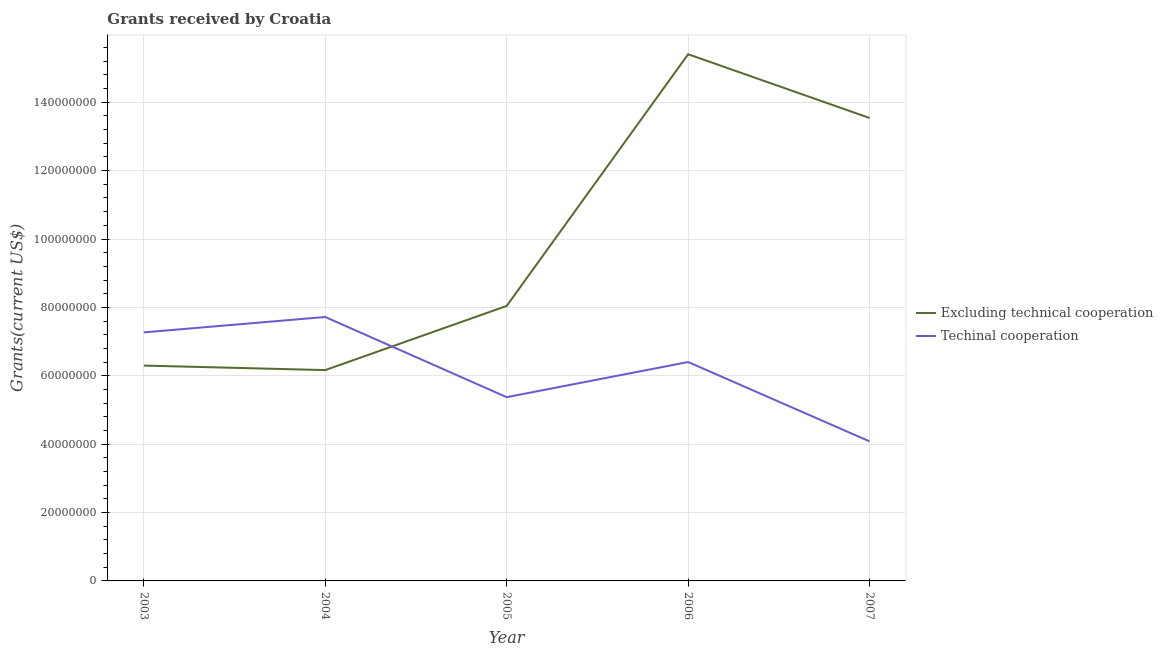What is the amount of grants received(including technical cooperation) in 2003?
Offer a terse response. 7.27e+07. Across all years, what is the maximum amount of grants received(excluding technical cooperation)?
Keep it short and to the point. 1.54e+08. Across all years, what is the minimum amount of grants received(excluding technical cooperation)?
Your response must be concise. 6.17e+07. What is the total amount of grants received(including technical cooperation) in the graph?
Make the answer very short. 3.08e+08. What is the difference between the amount of grants received(including technical cooperation) in 2004 and that in 2005?
Provide a succinct answer. 2.34e+07. What is the difference between the amount of grants received(including technical cooperation) in 2004 and the amount of grants received(excluding technical cooperation) in 2007?
Give a very brief answer. -5.82e+07. What is the average amount of grants received(including technical cooperation) per year?
Your answer should be very brief. 6.17e+07. In the year 2003, what is the difference between the amount of grants received(including technical cooperation) and amount of grants received(excluding technical cooperation)?
Your answer should be very brief. 9.71e+06. In how many years, is the amount of grants received(excluding technical cooperation) greater than 44000000 US$?
Your answer should be compact. 5. What is the ratio of the amount of grants received(excluding technical cooperation) in 2004 to that in 2005?
Your answer should be compact. 0.77. Is the amount of grants received(excluding technical cooperation) in 2005 less than that in 2006?
Offer a terse response. Yes. What is the difference between the highest and the second highest amount of grants received(including technical cooperation)?
Offer a very short reply. 4.50e+06. What is the difference between the highest and the lowest amount of grants received(excluding technical cooperation)?
Keep it short and to the point. 9.24e+07. Is the sum of the amount of grants received(excluding technical cooperation) in 2004 and 2005 greater than the maximum amount of grants received(including technical cooperation) across all years?
Your response must be concise. Yes. Is the amount of grants received(excluding technical cooperation) strictly less than the amount of grants received(including technical cooperation) over the years?
Give a very brief answer. No. Are the values on the major ticks of Y-axis written in scientific E-notation?
Give a very brief answer. No. Where does the legend appear in the graph?
Ensure brevity in your answer.  Center right. What is the title of the graph?
Keep it short and to the point. Grants received by Croatia. What is the label or title of the X-axis?
Your answer should be very brief. Year. What is the label or title of the Y-axis?
Provide a succinct answer. Grants(current US$). What is the Grants(current US$) of Excluding technical cooperation in 2003?
Make the answer very short. 6.30e+07. What is the Grants(current US$) of Techinal cooperation in 2003?
Ensure brevity in your answer.  7.27e+07. What is the Grants(current US$) of Excluding technical cooperation in 2004?
Keep it short and to the point. 6.17e+07. What is the Grants(current US$) in Techinal cooperation in 2004?
Keep it short and to the point. 7.72e+07. What is the Grants(current US$) of Excluding technical cooperation in 2005?
Provide a short and direct response. 8.04e+07. What is the Grants(current US$) of Techinal cooperation in 2005?
Offer a terse response. 5.37e+07. What is the Grants(current US$) of Excluding technical cooperation in 2006?
Provide a succinct answer. 1.54e+08. What is the Grants(current US$) in Techinal cooperation in 2006?
Your answer should be compact. 6.40e+07. What is the Grants(current US$) of Excluding technical cooperation in 2007?
Provide a short and direct response. 1.35e+08. What is the Grants(current US$) in Techinal cooperation in 2007?
Your answer should be very brief. 4.08e+07. Across all years, what is the maximum Grants(current US$) of Excluding technical cooperation?
Ensure brevity in your answer.  1.54e+08. Across all years, what is the maximum Grants(current US$) of Techinal cooperation?
Provide a succinct answer. 7.72e+07. Across all years, what is the minimum Grants(current US$) in Excluding technical cooperation?
Provide a succinct answer. 6.17e+07. Across all years, what is the minimum Grants(current US$) in Techinal cooperation?
Ensure brevity in your answer.  4.08e+07. What is the total Grants(current US$) in Excluding technical cooperation in the graph?
Ensure brevity in your answer.  4.94e+08. What is the total Grants(current US$) of Techinal cooperation in the graph?
Give a very brief answer. 3.08e+08. What is the difference between the Grants(current US$) of Excluding technical cooperation in 2003 and that in 2004?
Offer a very short reply. 1.32e+06. What is the difference between the Grants(current US$) of Techinal cooperation in 2003 and that in 2004?
Keep it short and to the point. -4.50e+06. What is the difference between the Grants(current US$) in Excluding technical cooperation in 2003 and that in 2005?
Keep it short and to the point. -1.74e+07. What is the difference between the Grants(current US$) in Techinal cooperation in 2003 and that in 2005?
Keep it short and to the point. 1.90e+07. What is the difference between the Grants(current US$) of Excluding technical cooperation in 2003 and that in 2006?
Provide a succinct answer. -9.11e+07. What is the difference between the Grants(current US$) in Techinal cooperation in 2003 and that in 2006?
Give a very brief answer. 8.67e+06. What is the difference between the Grants(current US$) of Excluding technical cooperation in 2003 and that in 2007?
Offer a very short reply. -7.24e+07. What is the difference between the Grants(current US$) in Techinal cooperation in 2003 and that in 2007?
Ensure brevity in your answer.  3.19e+07. What is the difference between the Grants(current US$) in Excluding technical cooperation in 2004 and that in 2005?
Ensure brevity in your answer.  -1.88e+07. What is the difference between the Grants(current US$) of Techinal cooperation in 2004 and that in 2005?
Offer a terse response. 2.34e+07. What is the difference between the Grants(current US$) of Excluding technical cooperation in 2004 and that in 2006?
Give a very brief answer. -9.24e+07. What is the difference between the Grants(current US$) in Techinal cooperation in 2004 and that in 2006?
Your answer should be very brief. 1.32e+07. What is the difference between the Grants(current US$) in Excluding technical cooperation in 2004 and that in 2007?
Ensure brevity in your answer.  -7.37e+07. What is the difference between the Grants(current US$) in Techinal cooperation in 2004 and that in 2007?
Provide a succinct answer. 3.64e+07. What is the difference between the Grants(current US$) of Excluding technical cooperation in 2005 and that in 2006?
Keep it short and to the point. -7.36e+07. What is the difference between the Grants(current US$) in Techinal cooperation in 2005 and that in 2006?
Your answer should be very brief. -1.03e+07. What is the difference between the Grants(current US$) in Excluding technical cooperation in 2005 and that in 2007?
Offer a very short reply. -5.50e+07. What is the difference between the Grants(current US$) of Techinal cooperation in 2005 and that in 2007?
Your answer should be very brief. 1.29e+07. What is the difference between the Grants(current US$) in Excluding technical cooperation in 2006 and that in 2007?
Offer a terse response. 1.86e+07. What is the difference between the Grants(current US$) of Techinal cooperation in 2006 and that in 2007?
Your answer should be very brief. 2.32e+07. What is the difference between the Grants(current US$) of Excluding technical cooperation in 2003 and the Grants(current US$) of Techinal cooperation in 2004?
Provide a short and direct response. -1.42e+07. What is the difference between the Grants(current US$) of Excluding technical cooperation in 2003 and the Grants(current US$) of Techinal cooperation in 2005?
Provide a succinct answer. 9.24e+06. What is the difference between the Grants(current US$) of Excluding technical cooperation in 2003 and the Grants(current US$) of Techinal cooperation in 2006?
Provide a short and direct response. -1.04e+06. What is the difference between the Grants(current US$) of Excluding technical cooperation in 2003 and the Grants(current US$) of Techinal cooperation in 2007?
Make the answer very short. 2.22e+07. What is the difference between the Grants(current US$) in Excluding technical cooperation in 2004 and the Grants(current US$) in Techinal cooperation in 2005?
Offer a very short reply. 7.92e+06. What is the difference between the Grants(current US$) of Excluding technical cooperation in 2004 and the Grants(current US$) of Techinal cooperation in 2006?
Your response must be concise. -2.36e+06. What is the difference between the Grants(current US$) of Excluding technical cooperation in 2004 and the Grants(current US$) of Techinal cooperation in 2007?
Your answer should be compact. 2.08e+07. What is the difference between the Grants(current US$) of Excluding technical cooperation in 2005 and the Grants(current US$) of Techinal cooperation in 2006?
Your answer should be compact. 1.64e+07. What is the difference between the Grants(current US$) of Excluding technical cooperation in 2005 and the Grants(current US$) of Techinal cooperation in 2007?
Make the answer very short. 3.96e+07. What is the difference between the Grants(current US$) in Excluding technical cooperation in 2006 and the Grants(current US$) in Techinal cooperation in 2007?
Your response must be concise. 1.13e+08. What is the average Grants(current US$) of Excluding technical cooperation per year?
Your response must be concise. 9.89e+07. What is the average Grants(current US$) of Techinal cooperation per year?
Keep it short and to the point. 6.17e+07. In the year 2003, what is the difference between the Grants(current US$) of Excluding technical cooperation and Grants(current US$) of Techinal cooperation?
Provide a short and direct response. -9.71e+06. In the year 2004, what is the difference between the Grants(current US$) in Excluding technical cooperation and Grants(current US$) in Techinal cooperation?
Ensure brevity in your answer.  -1.55e+07. In the year 2005, what is the difference between the Grants(current US$) of Excluding technical cooperation and Grants(current US$) of Techinal cooperation?
Your answer should be compact. 2.67e+07. In the year 2006, what is the difference between the Grants(current US$) of Excluding technical cooperation and Grants(current US$) of Techinal cooperation?
Offer a very short reply. 9.00e+07. In the year 2007, what is the difference between the Grants(current US$) of Excluding technical cooperation and Grants(current US$) of Techinal cooperation?
Provide a short and direct response. 9.46e+07. What is the ratio of the Grants(current US$) in Excluding technical cooperation in 2003 to that in 2004?
Offer a terse response. 1.02. What is the ratio of the Grants(current US$) in Techinal cooperation in 2003 to that in 2004?
Provide a succinct answer. 0.94. What is the ratio of the Grants(current US$) of Excluding technical cooperation in 2003 to that in 2005?
Give a very brief answer. 0.78. What is the ratio of the Grants(current US$) in Techinal cooperation in 2003 to that in 2005?
Give a very brief answer. 1.35. What is the ratio of the Grants(current US$) in Excluding technical cooperation in 2003 to that in 2006?
Your answer should be compact. 0.41. What is the ratio of the Grants(current US$) in Techinal cooperation in 2003 to that in 2006?
Keep it short and to the point. 1.14. What is the ratio of the Grants(current US$) in Excluding technical cooperation in 2003 to that in 2007?
Offer a very short reply. 0.47. What is the ratio of the Grants(current US$) of Techinal cooperation in 2003 to that in 2007?
Offer a very short reply. 1.78. What is the ratio of the Grants(current US$) in Excluding technical cooperation in 2004 to that in 2005?
Ensure brevity in your answer.  0.77. What is the ratio of the Grants(current US$) of Techinal cooperation in 2004 to that in 2005?
Your answer should be compact. 1.44. What is the ratio of the Grants(current US$) of Excluding technical cooperation in 2004 to that in 2006?
Your answer should be very brief. 0.4. What is the ratio of the Grants(current US$) of Techinal cooperation in 2004 to that in 2006?
Keep it short and to the point. 1.21. What is the ratio of the Grants(current US$) of Excluding technical cooperation in 2004 to that in 2007?
Make the answer very short. 0.46. What is the ratio of the Grants(current US$) of Techinal cooperation in 2004 to that in 2007?
Ensure brevity in your answer.  1.89. What is the ratio of the Grants(current US$) of Excluding technical cooperation in 2005 to that in 2006?
Offer a terse response. 0.52. What is the ratio of the Grants(current US$) in Techinal cooperation in 2005 to that in 2006?
Make the answer very short. 0.84. What is the ratio of the Grants(current US$) of Excluding technical cooperation in 2005 to that in 2007?
Offer a very short reply. 0.59. What is the ratio of the Grants(current US$) of Techinal cooperation in 2005 to that in 2007?
Offer a very short reply. 1.32. What is the ratio of the Grants(current US$) of Excluding technical cooperation in 2006 to that in 2007?
Keep it short and to the point. 1.14. What is the ratio of the Grants(current US$) in Techinal cooperation in 2006 to that in 2007?
Your response must be concise. 1.57. What is the difference between the highest and the second highest Grants(current US$) of Excluding technical cooperation?
Make the answer very short. 1.86e+07. What is the difference between the highest and the second highest Grants(current US$) in Techinal cooperation?
Provide a short and direct response. 4.50e+06. What is the difference between the highest and the lowest Grants(current US$) in Excluding technical cooperation?
Offer a very short reply. 9.24e+07. What is the difference between the highest and the lowest Grants(current US$) in Techinal cooperation?
Ensure brevity in your answer.  3.64e+07. 